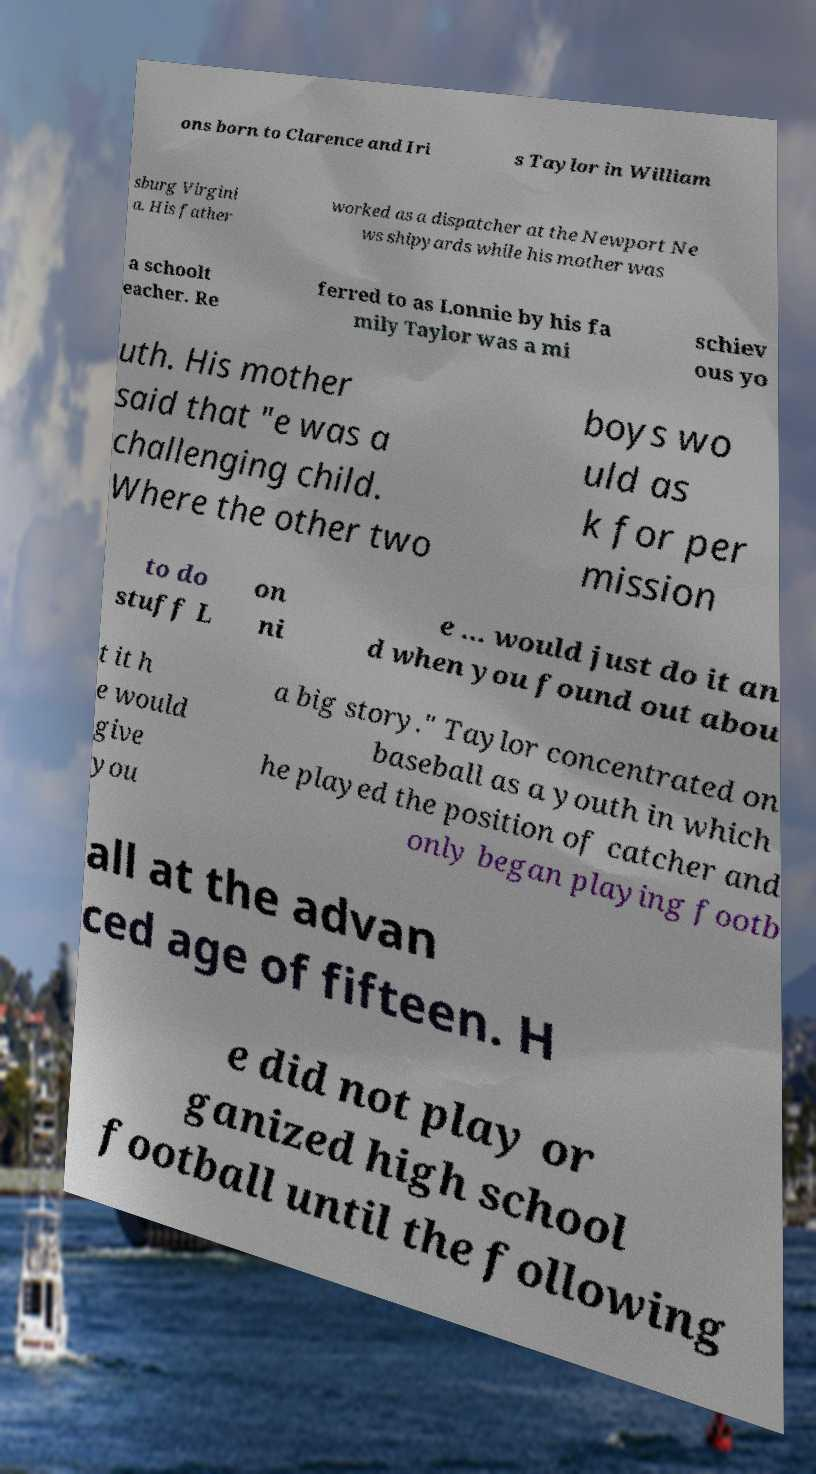I need the written content from this picture converted into text. Can you do that? ons born to Clarence and Iri s Taylor in William sburg Virgini a. His father worked as a dispatcher at the Newport Ne ws shipyards while his mother was a schoolt eacher. Re ferred to as Lonnie by his fa mily Taylor was a mi schiev ous yo uth. His mother said that "e was a challenging child. Where the other two boys wo uld as k for per mission to do stuff L on ni e ... would just do it an d when you found out abou t it h e would give you a big story." Taylor concentrated on baseball as a youth in which he played the position of catcher and only began playing footb all at the advan ced age of fifteen. H e did not play or ganized high school football until the following 